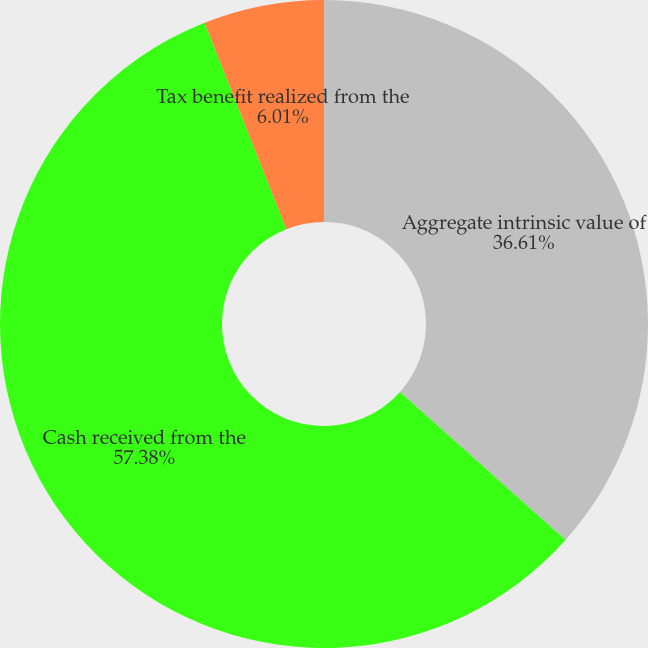Convert chart. <chart><loc_0><loc_0><loc_500><loc_500><pie_chart><fcel>Aggregate intrinsic value of<fcel>Cash received from the<fcel>Tax benefit realized from the<nl><fcel>36.61%<fcel>57.38%<fcel>6.01%<nl></chart> 